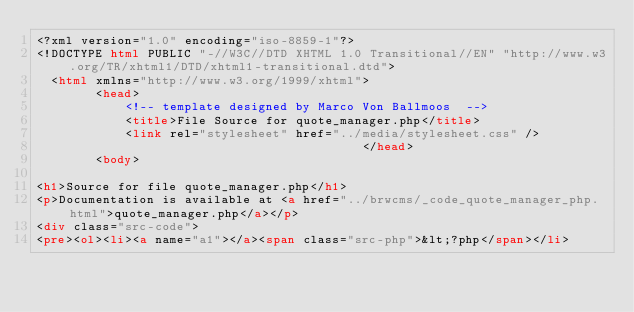<code> <loc_0><loc_0><loc_500><loc_500><_HTML_><?xml version="1.0" encoding="iso-8859-1"?>
<!DOCTYPE html PUBLIC "-//W3C//DTD XHTML 1.0 Transitional//EN" "http://www.w3.org/TR/xhtml1/DTD/xhtml1-transitional.dtd">
  <html xmlns="http://www.w3.org/1999/xhtml">
		<head>
			<!-- template designed by Marco Von Ballmoos  -->
			<title>File Source for quote_manager.php</title>
			<link rel="stylesheet" href="../media/stylesheet.css" />
											</head>
		<body>
						<h1>Source for file quote_manager.php</h1>
<p>Documentation is available at <a href="../brwcms/_code_quote_manager_php.html">quote_manager.php</a></p>
<div class="src-code">
<pre><ol><li><a name="a1"></a><span class="src-php">&lt;?php</span></li></code> 